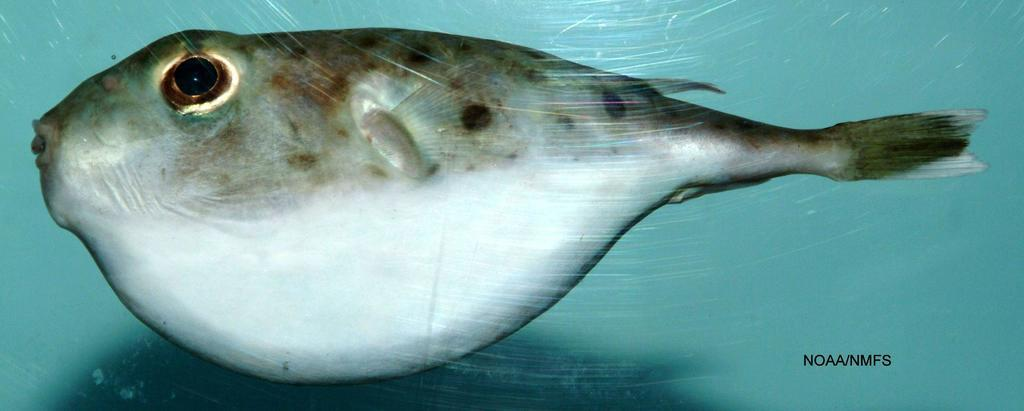What type of animal can be seen in the water in the image? There is a fish in the water in the image. What type of discussion is taking place at the zoo in the image? There is no discussion or zoo present in the image; it only features a fish in the water. 